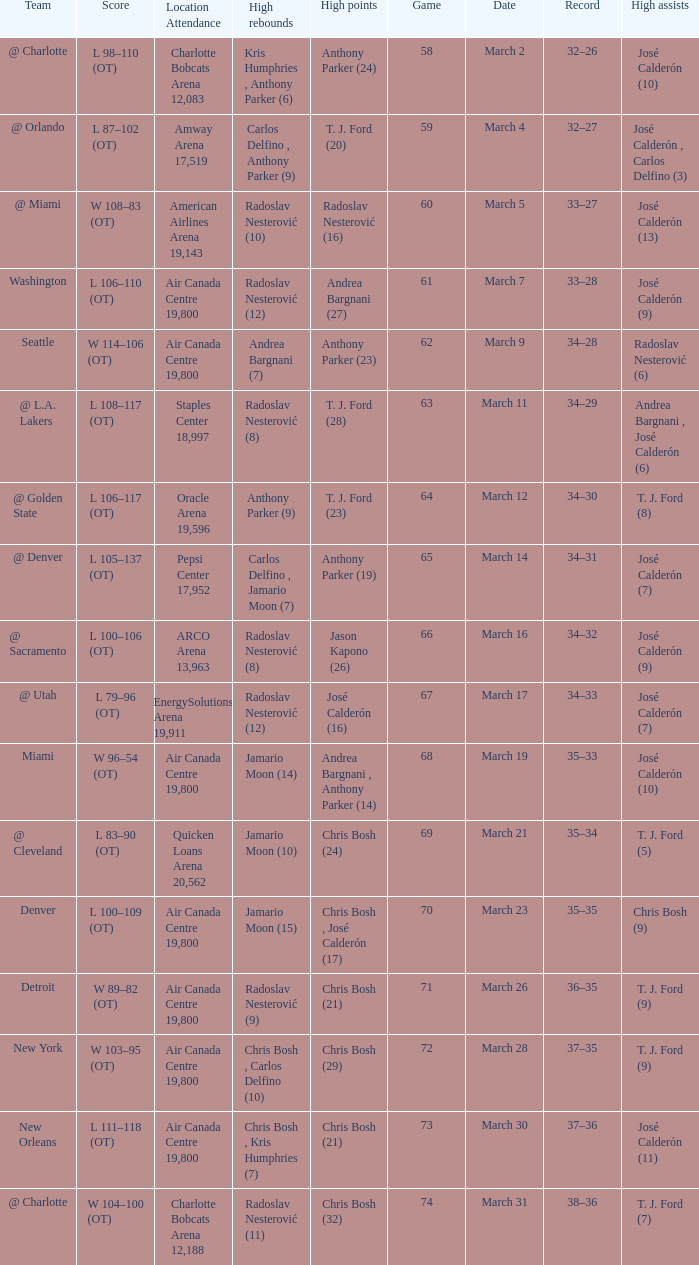How many attended the game on march 16 after over 64 games? ARCO Arena 13,963. 